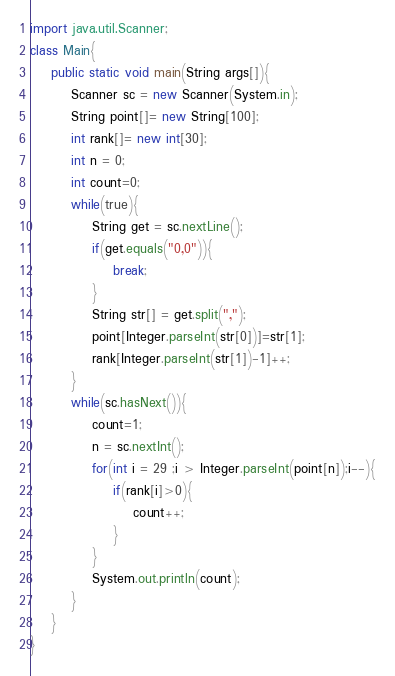Convert code to text. <code><loc_0><loc_0><loc_500><loc_500><_Java_>import java.util.Scanner;
class Main{
	public static void main(String args[]){
		Scanner sc = new Scanner(System.in);
		String point[]= new String[100];
		int rank[]= new int[30];
		int n = 0;
		int count=0;
		while(true){
			String get = sc.nextLine();
			if(get.equals("0,0")){
				break;
			}
			String str[] = get.split(",");
			point[Integer.parseInt(str[0])]=str[1];
			rank[Integer.parseInt(str[1])-1]++;
		}
		while(sc.hasNext()){
			count=1;
			n = sc.nextInt();
			for(int i = 29 ;i > Integer.parseInt(point[n]);i--){
				if(rank[i]>0){
					count++;
				}
			}
			System.out.println(count);
		}
	}	
}</code> 